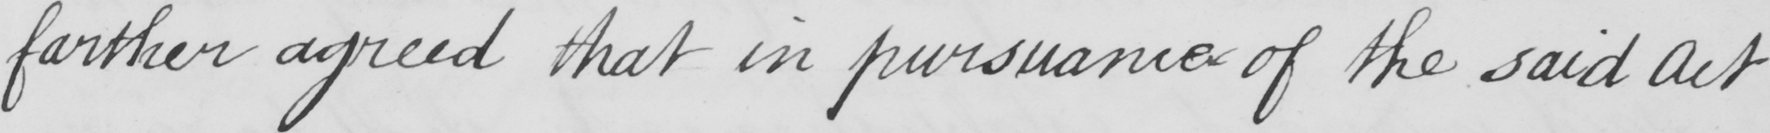Please provide the text content of this handwritten line. farther agreed that in pursuance of the said Act 